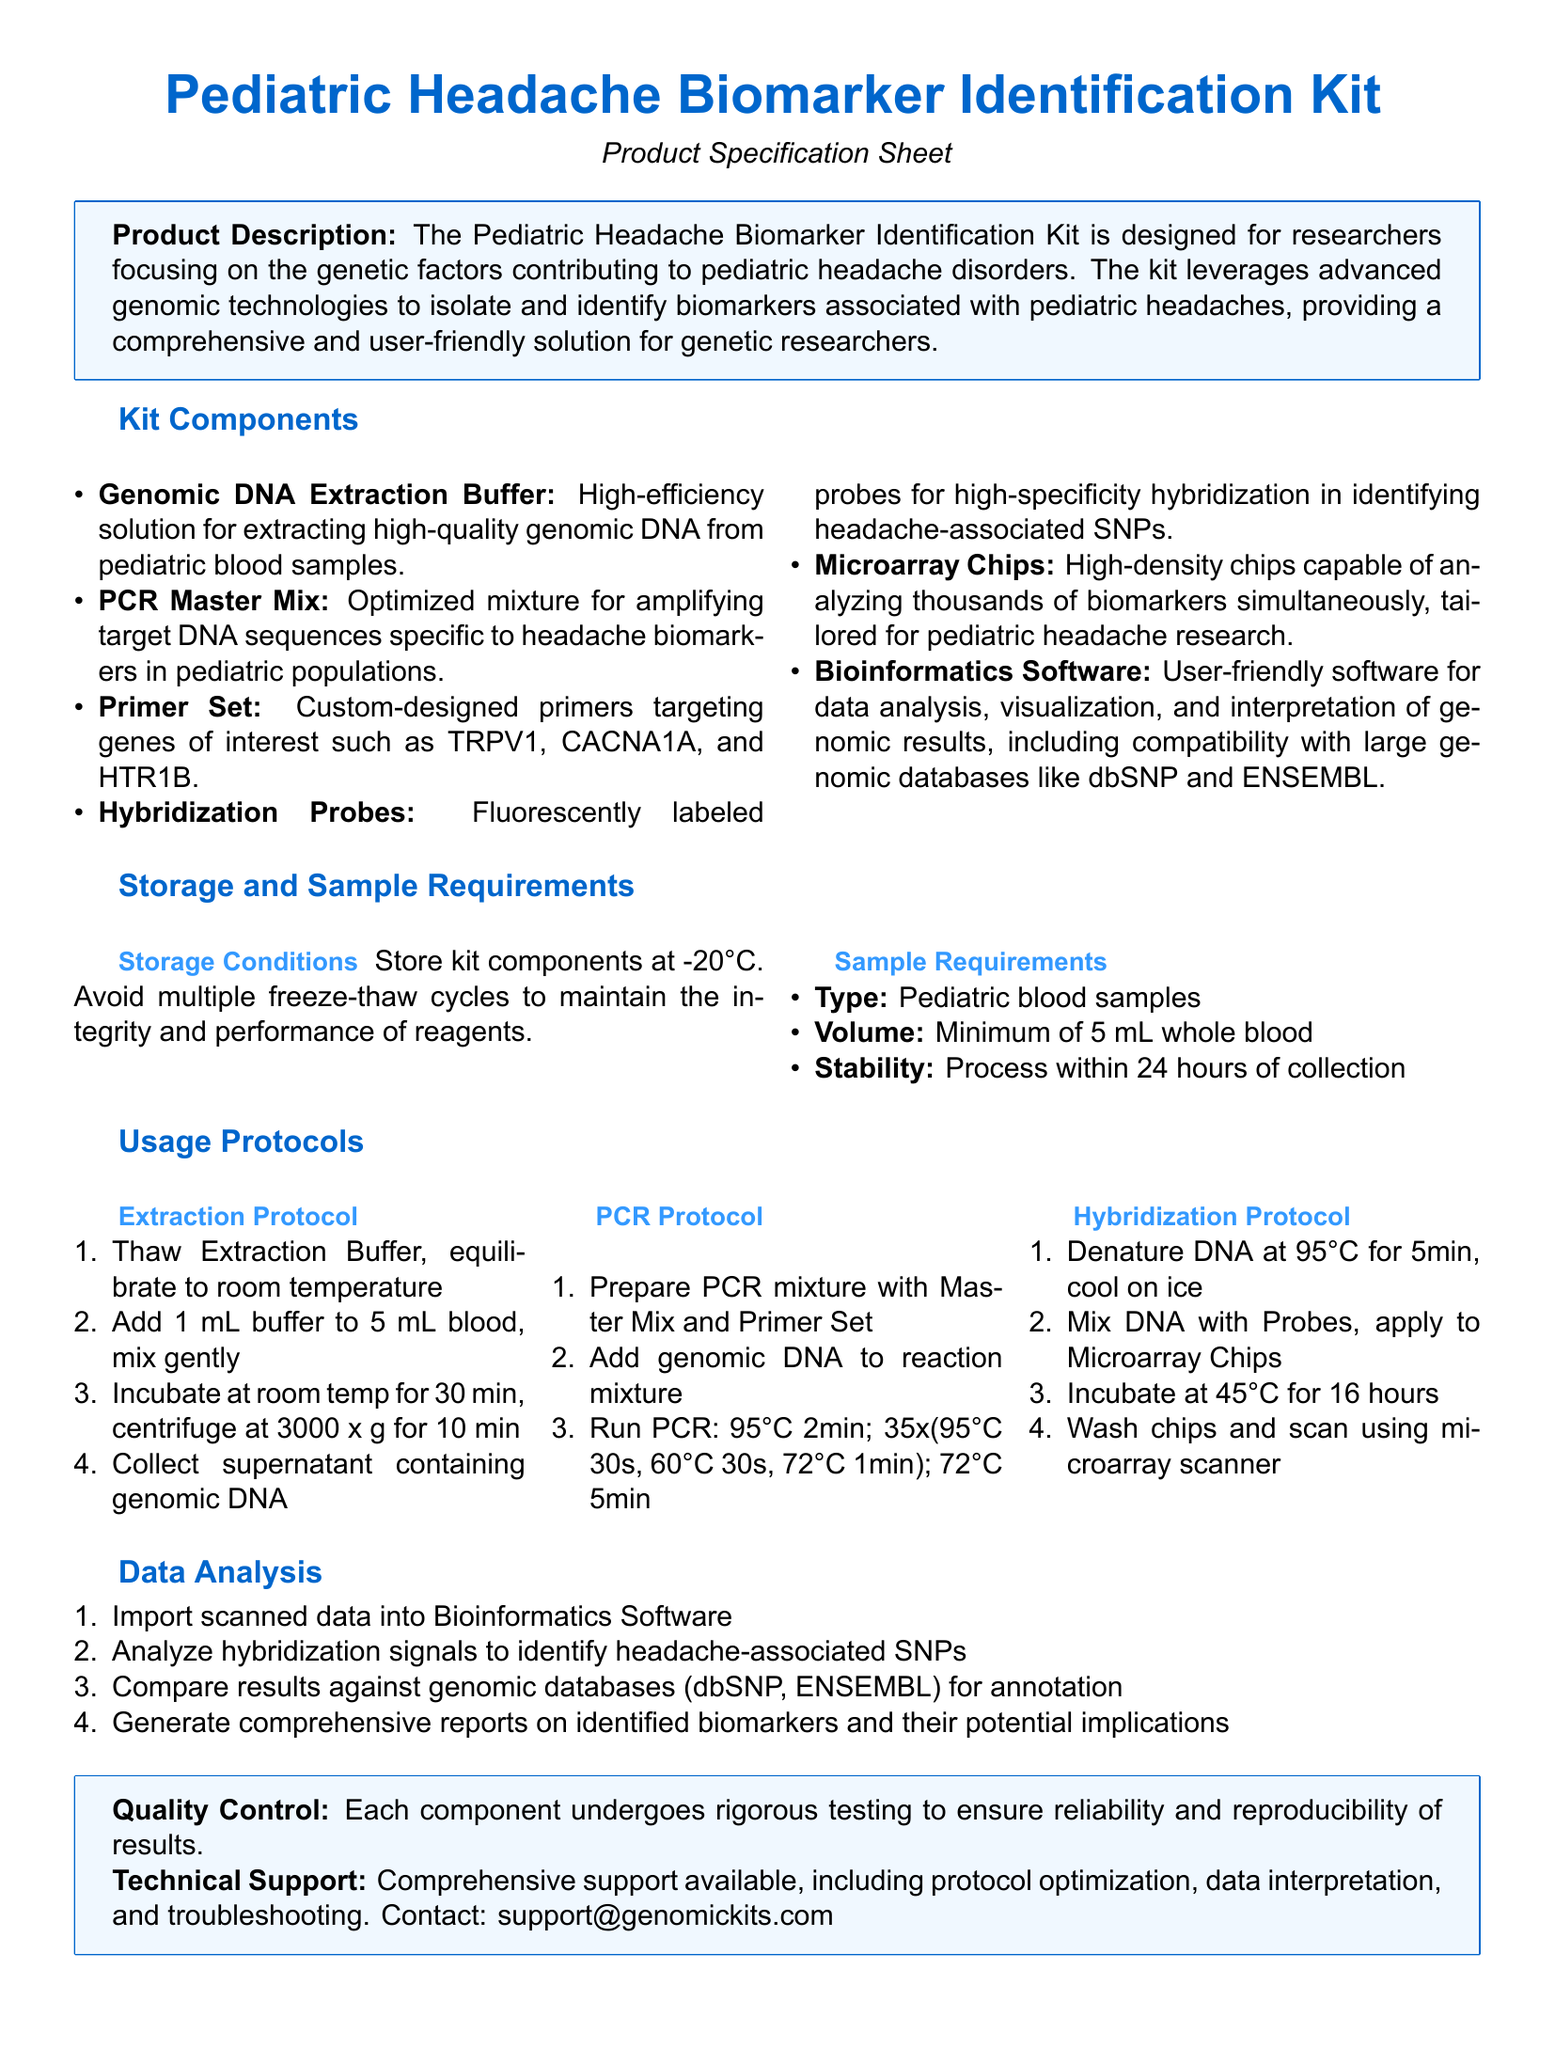What is the main purpose of the Pediatric Headache Biomarker Identification Kit? The main purpose is to identify biomarkers associated with pediatric headache disorders using genomic technologies.
Answer: Identify biomarkers How many mL of blood samples are required? The document specifies a minimum volume of blood samples needed for the extraction process.
Answer: 5 mL What temperature should kit components be stored at? The storage conditions section indicates the temperature required for the kit components.
Answer: -20°C Which genes are targeted by the custom-designed primer set? The primer set targets specific genes relevant to headache disorders, as listed in the components section.
Answer: TRPV1, CACNA1A, HTR1B What is the first step in the extraction protocol? The extraction protocol outlines the initial action required for sample processing.
Answer: Thaw Extraction Buffer What should be avoided to maintain the integrity of reagents? The storage conditions section mentions a specific action that should not be done to protect the reagents.
Answer: Multiple freeze-thaw cycles How is data analysis performed? The data analysis section outlines the steps that researchers must take to analyze the gathered data.
Answer: Import scanned data What does the kit include for data analysis? The components section indicates the specific software included with the kit for analyzing data.
Answer: Bioinformatics Software What type of support is offered with the kit? The technical support section details the nature of assistance provided to users of the kit.
Answer: Comprehensive support 